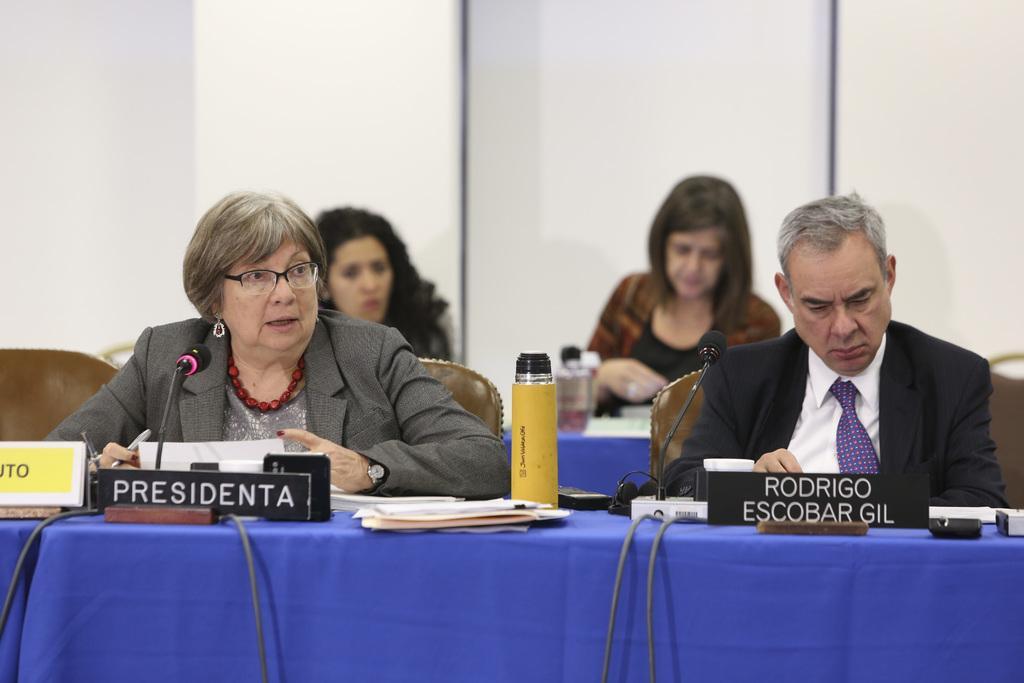How would you summarize this image in a sentence or two? These persons are sitting on a chair. In-front of this person there is a table, on this table there is a cloth, bottle, mic and papers. 